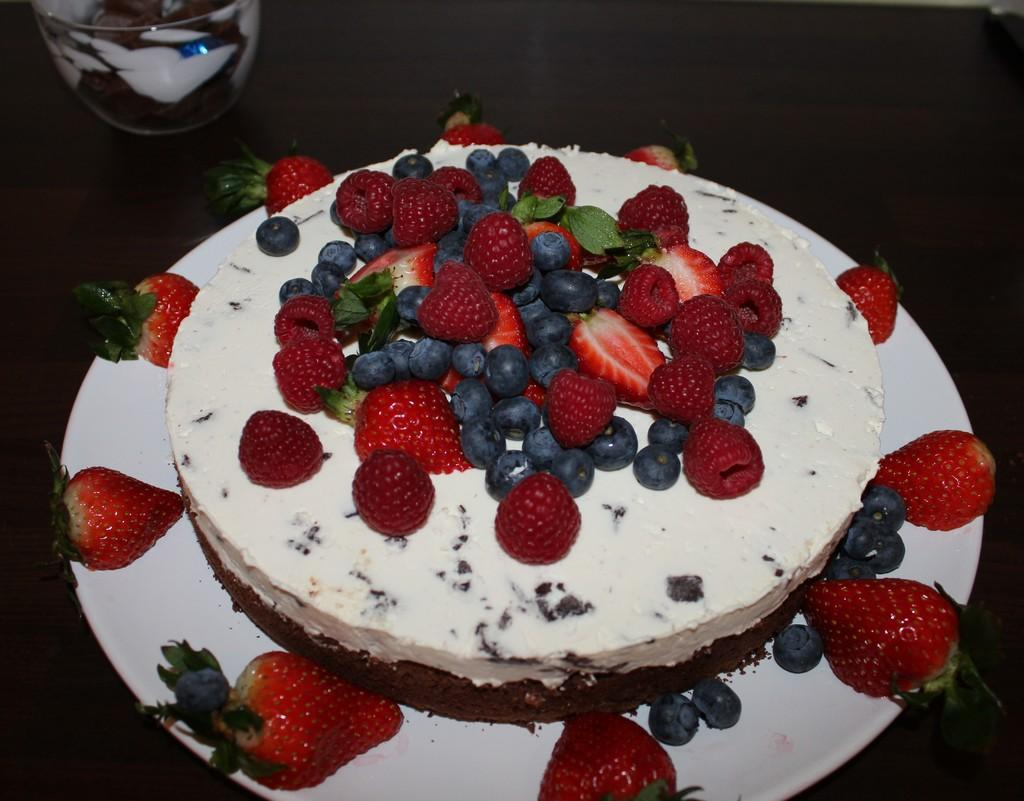What is the main food item in the image? There is a cake in the image. What fruits are present in the image? There are strawberries and grapes in the image. On what is the cake and fruits placed? The items are placed on a white plate. What other dish can be seen in the image? There is a bowl in the image. How would you describe the overall lighting or color of the background in the image? The background of the image is dark. What type of skirt is draped over the bowl in the image? There is no skirt present in the image; it only features a cake, fruits, a white plate, and a bowl. 